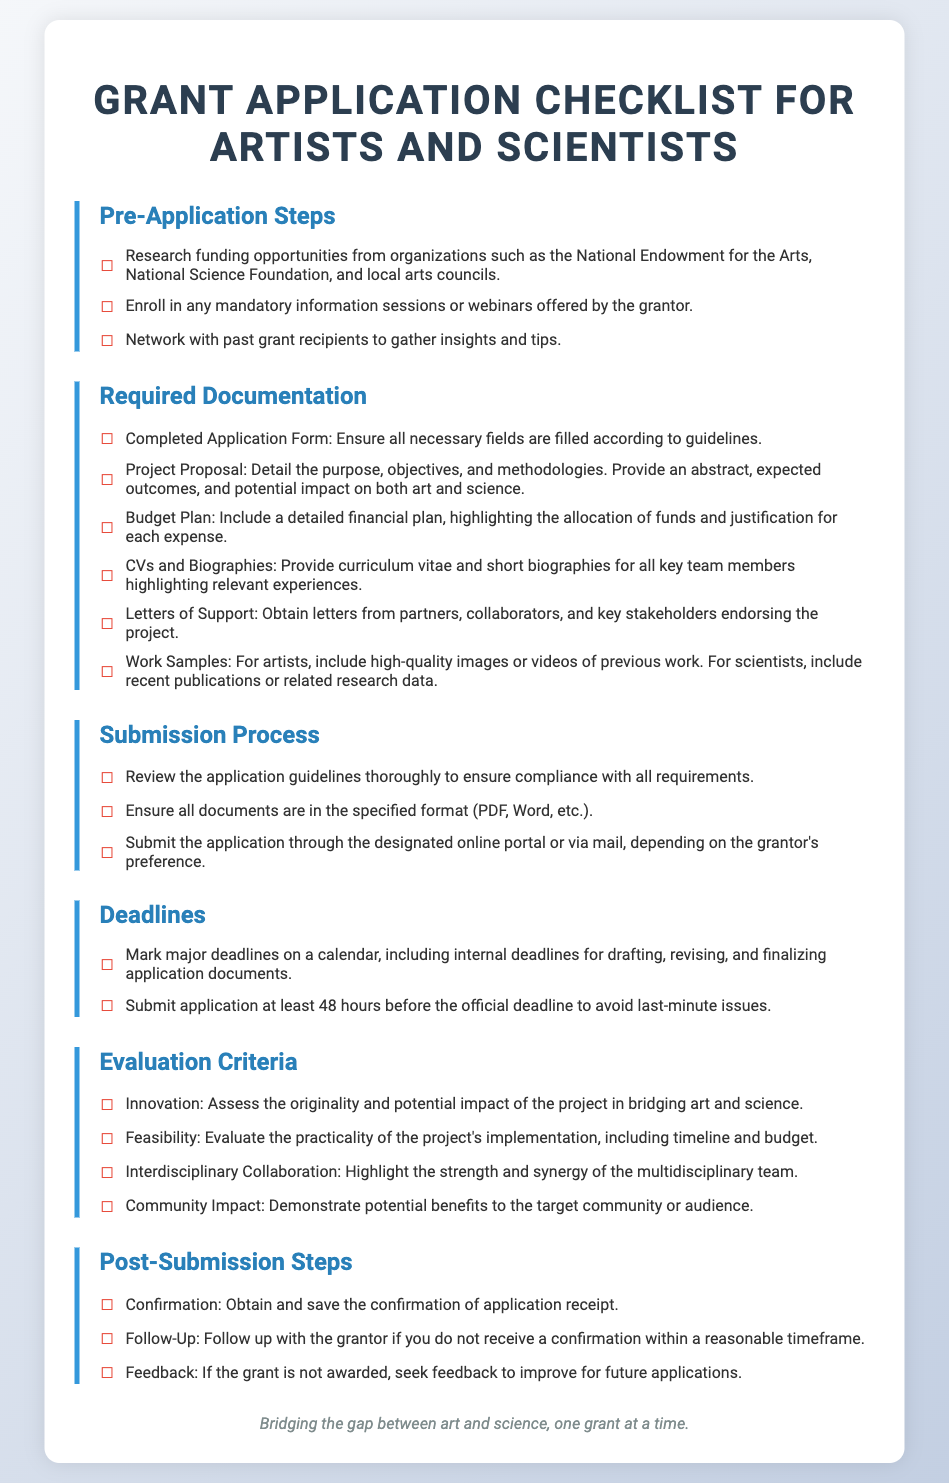what is the title of the document? The title prominently displayed at the top of the document is the main identifier of it.
Answer: Grant Application Checklist for Artists and Scientists how many sections are there in the document? The document is divided into various distinct areas, each titled separately, indicating different steps and requirements.
Answer: 6 what should you include in the budget plan? The budget plan requires specific details outlined in the document regarding finances.
Answer: Detailed financial plan who should provide letters of support? The document specifies who should endorse the project, which is essential for applications.
Answer: Partners, collaborators, and key stakeholders what is the recommended timeframe for submitting the application? The document provides a guideline for submission timing to avoid last-minute complications.
Answer: 48 hours what is a key evaluation criterion related to project originality? The evaluation criteria in the document help assess several important aspects of the project.
Answer: Innovation what is the post-submission confirmation step? The document outlines the steps to follow after submitting the application for tracking purposes.
Answer: Obtain and save the confirmation of application receipt what is one way to prepare for the application process? The checklist includes steps artists and scientists can take before applying to ensure they are ready.
Answer: Research funding opportunities what should be highlighted in the project proposal? The document details essential content to be included in project proposals for clarity.
Answer: Purpose, objectives, and methodologies 